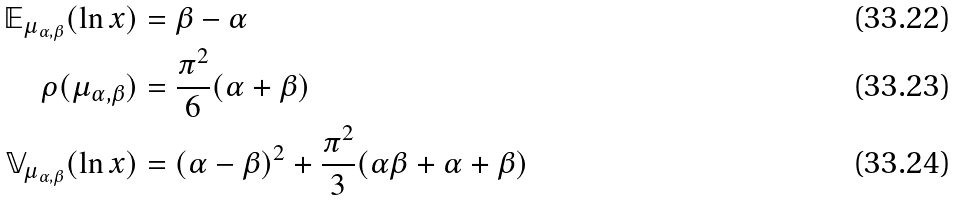Convert formula to latex. <formula><loc_0><loc_0><loc_500><loc_500>\mathbb { E } _ { \mu _ { \alpha , \beta } } ( \ln x ) & = \beta - \alpha \\ \rho ( \mu _ { \alpha , \beta } ) & = \frac { \pi ^ { 2 } } { 6 } ( \alpha + \beta ) \\ \mathbb { V } _ { \mu _ { \alpha , \beta } } ( \ln x ) & = ( \alpha - \beta ) ^ { 2 } + \frac { \pi ^ { 2 } } { 3 } ( \alpha \beta + \alpha + \beta )</formula> 